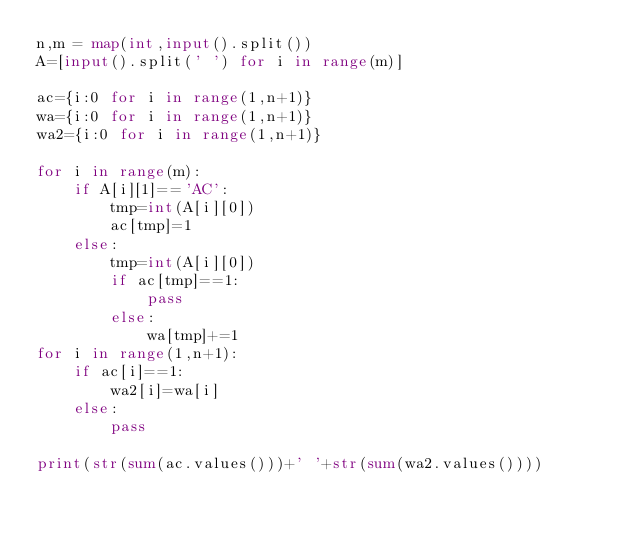<code> <loc_0><loc_0><loc_500><loc_500><_Python_>n,m = map(int,input().split())
A=[input().split(' ') for i in range(m)]
 
ac={i:0 for i in range(1,n+1)}
wa={i:0 for i in range(1,n+1)}
wa2={i:0 for i in range(1,n+1)}
 
for i in range(m):
    if A[i][1]=='AC':
        tmp=int(A[i][0])
        ac[tmp]=1
    else:
        tmp=int(A[i][0])
        if ac[tmp]==1:
            pass
        else:
            wa[tmp]+=1
for i in range(1,n+1):
    if ac[i]==1:
        wa2[i]=wa[i]
    else:
        pass

print(str(sum(ac.values()))+' '+str(sum(wa2.values())))</code> 